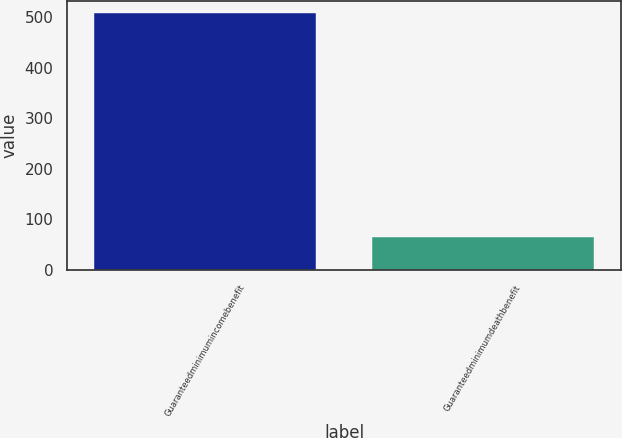<chart> <loc_0><loc_0><loc_500><loc_500><bar_chart><fcel>Guaranteedminimumincomebenefit<fcel>Guaranteedminimumdeathbenefit<nl><fcel>507<fcel>66<nl></chart> 